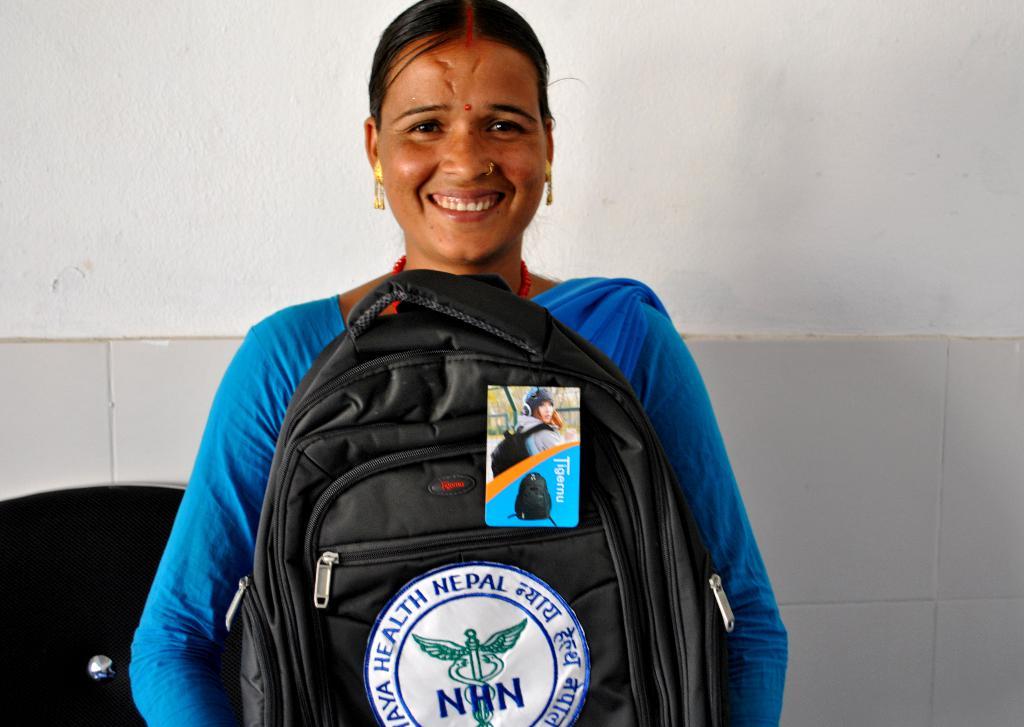What does the logo on the backpack say?
Offer a very short reply. Nhn. What country is this from/?
Keep it short and to the point. Nepal. 